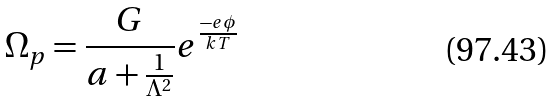Convert formula to latex. <formula><loc_0><loc_0><loc_500><loc_500>\Omega _ { p } = \frac { G } { a + \frac { 1 } { \Lambda ^ { 2 } } } e ^ { \frac { - e \phi } { k T } }</formula> 